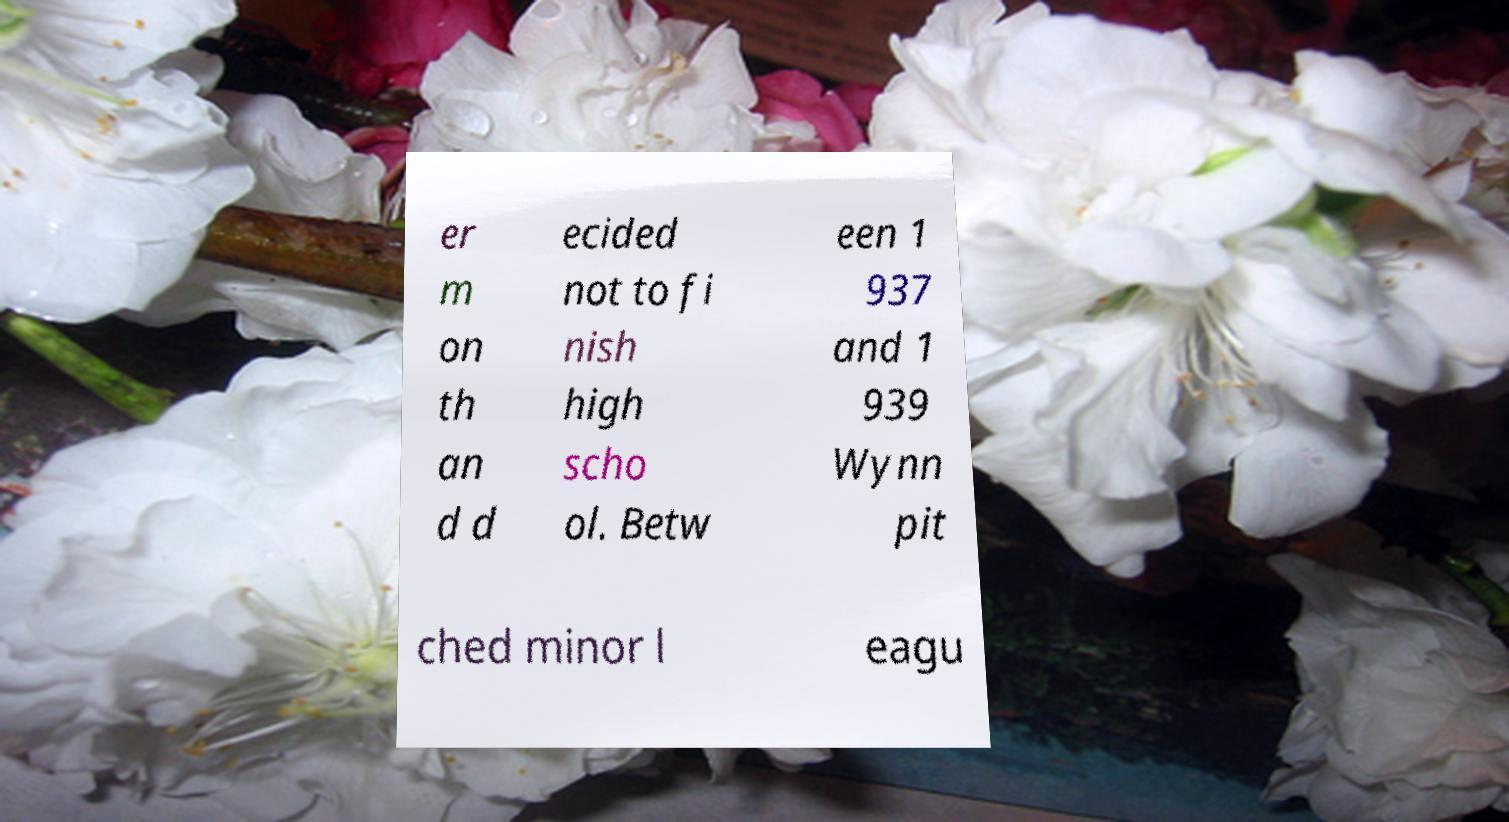Please read and relay the text visible in this image. What does it say? er m on th an d d ecided not to fi nish high scho ol. Betw een 1 937 and 1 939 Wynn pit ched minor l eagu 